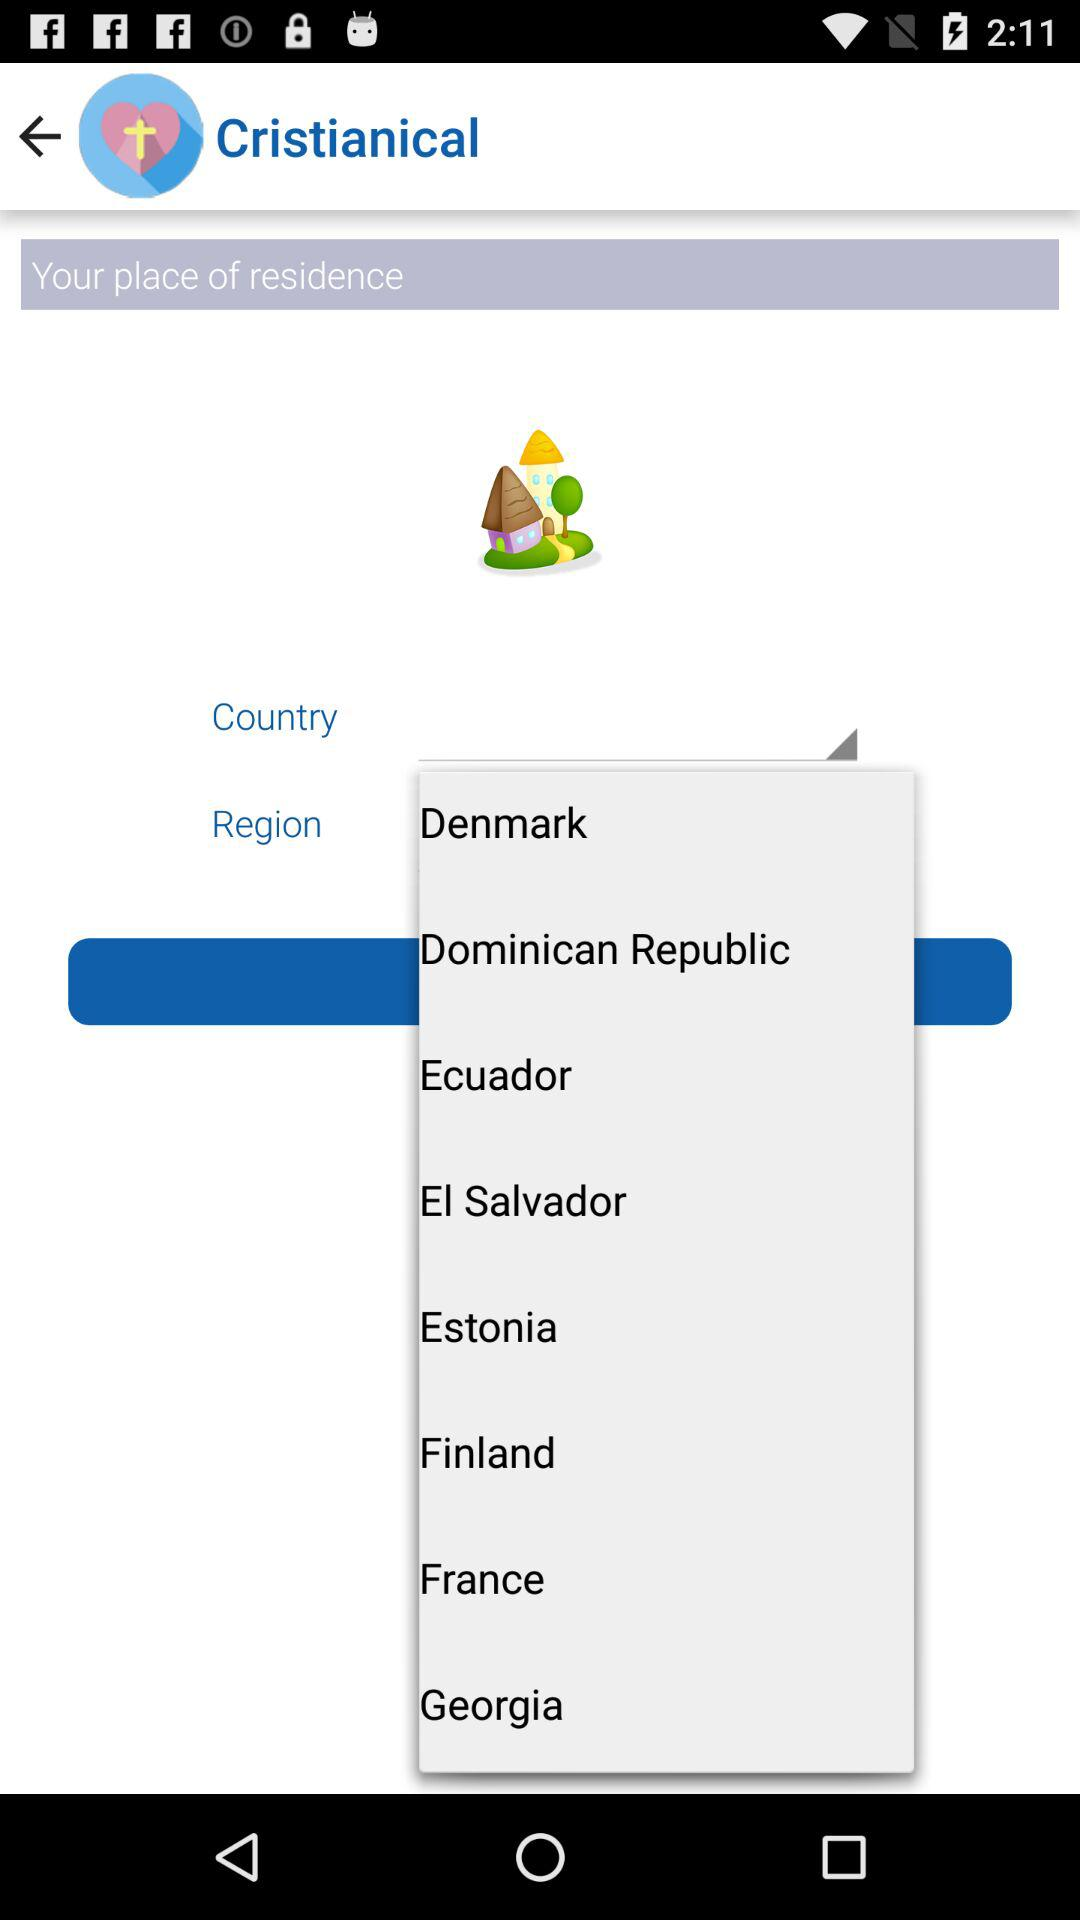What's the selected Country?
When the provided information is insufficient, respond with <no answer>. <no answer> 